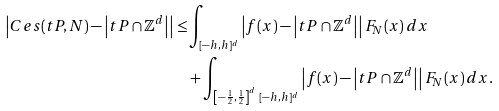Convert formula to latex. <formula><loc_0><loc_0><loc_500><loc_500>\left | C e s ( t P , N ) - \left | t P \cap \mathbb { Z } ^ { d } \right | \right | \leq & \int _ { [ - h , h ] ^ { d } } \left | f ( x ) - \left | t P \cap \mathbb { Z } ^ { d } \right | \right | F _ { N } ( x ) \, d x \\ & + \int _ { \left [ - \frac { 1 } { 2 } , \frac { 1 } { 2 } \right ] ^ { d } \ [ - h , h ] ^ { d } } \left | f ( x ) - \left | t P \cap \mathbb { Z } ^ { d } \right | \right | F _ { N } ( x ) \, d x .</formula> 